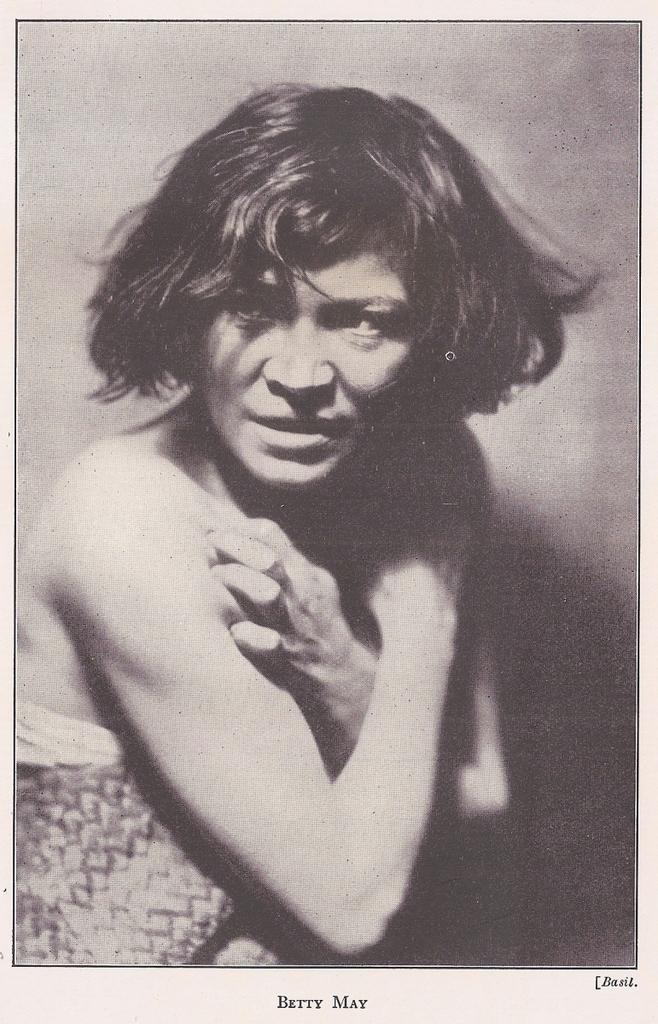What is the main subject of the image? The main subject of the image is an old picture of a person. Can you describe any additional details about the image? Yes, there is text written at the bottom of the image. What type of wood can be seen in the background of the image? There is no wood visible in the background of the image; it features an old picture of a person with text at the bottom. 